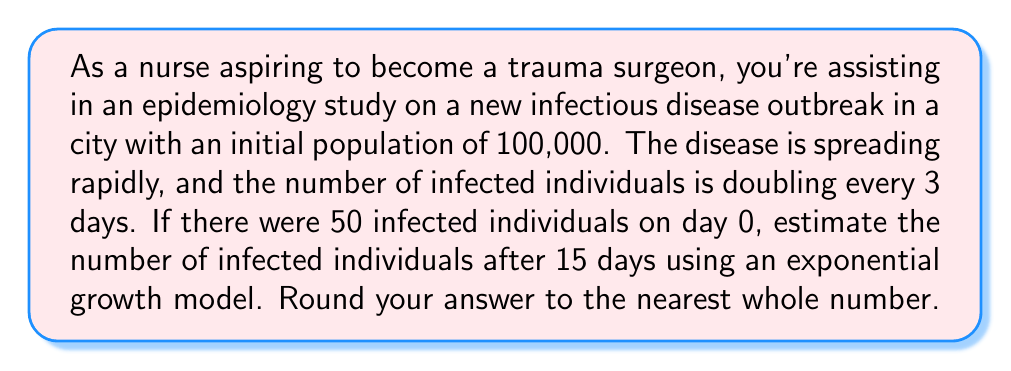Help me with this question. Let's approach this step-by-step using an exponential growth model:

1) The general form of an exponential growth model is:

   $$P(t) = P_0 \cdot e^{rt}$$

   Where:
   $P(t)$ is the population at time $t$
   $P_0$ is the initial population
   $r$ is the growth rate
   $t$ is the time

2) We're given that the population doubles every 3 days. We can use this to find the growth rate $r$:

   $$2 = e^{3r}$$

   Taking the natural log of both sides:

   $$\ln(2) = 3r$$

   $$r = \frac{\ln(2)}{3} \approx 0.2310$$

3) Now we have all the components for our model:
   $P_0 = 50$ (initial infected population)
   $r \approx 0.2310$
   $t = 15$ (days)

4) Plugging these into our exponential growth formula:

   $$P(15) = 50 \cdot e^{0.2310 \cdot 15}$$

5) Calculating this:

   $$P(15) = 50 \cdot e^{3.465} \approx 50 \cdot 31.9654 \approx 1598.27$$

6) Rounding to the nearest whole number:

   $$P(15) \approx 1598$$
Answer: 1598 infected individuals 